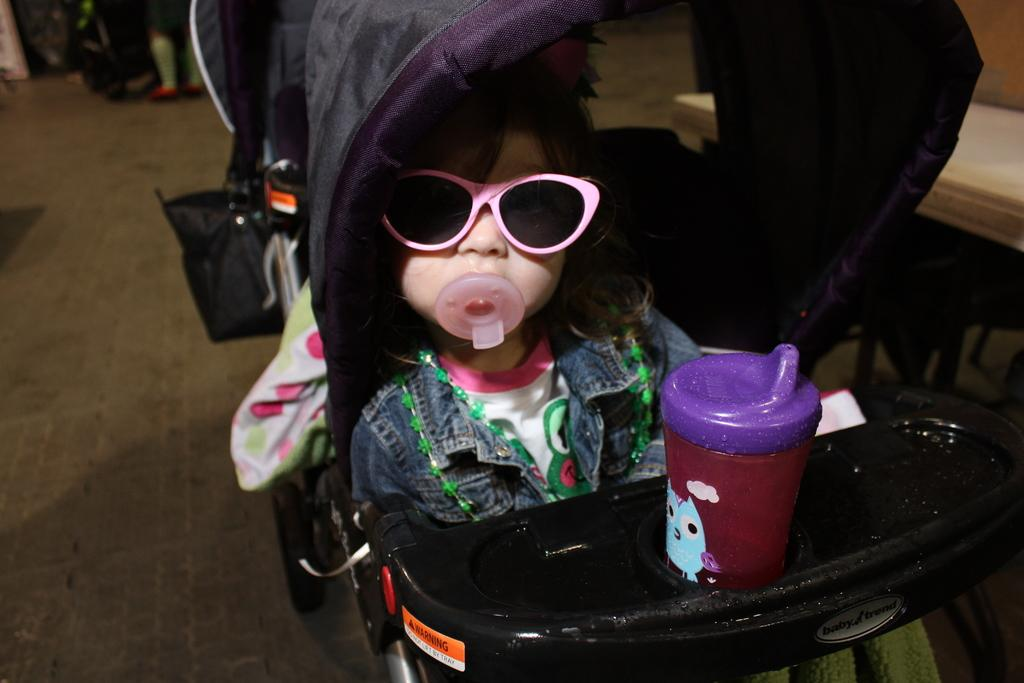What is the main subject of the image? The main subject of the image is a kid. What is the kid doing in the image? The kid is sitting in a walker. Where is the walker located in the image? The walker is on the road. What type of fowl can be seen walking alongside the kid in the image? There is no fowl present in the image; the kid is sitting in a walker on the road. What book is the kid reading while sitting in the walker in the image? There is no book or reading activity depicted in the image; the kid is simply sitting in the walker on the road. 